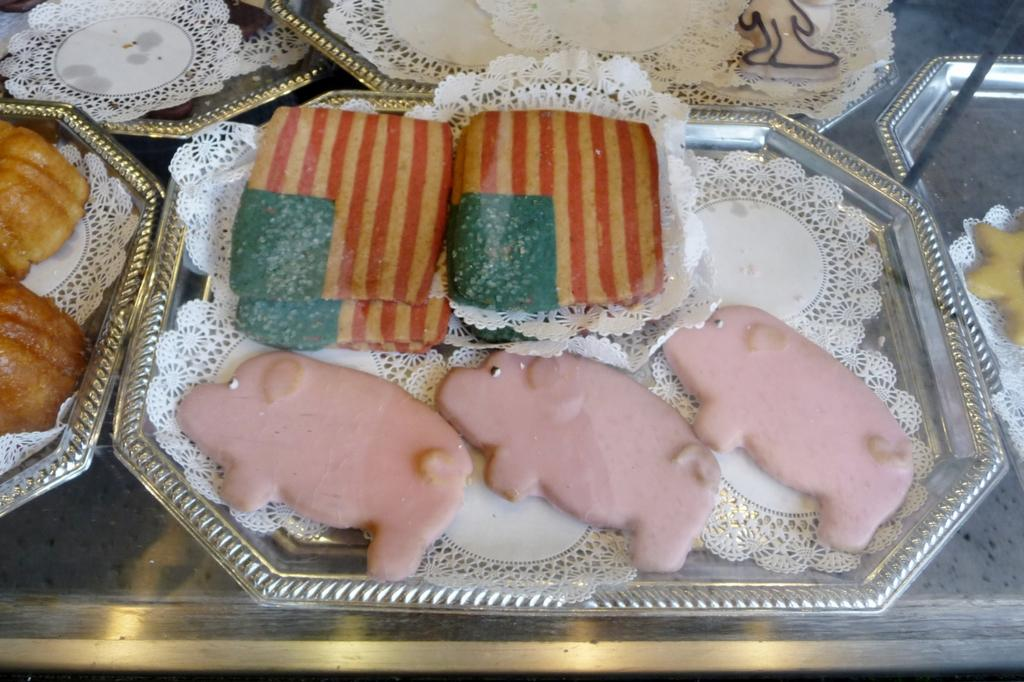How many trays with food items can be seen in the image? There are five trays with food items in the image. What else can be seen in the image besides the trays? There are plates visible in the image. Where might the trays and plates be located in the image? The trays and plates may be on a table in the image. In which type of setting is the image taken? The image is taken in a room. How many trampolines are visible in the image? There are no trampolines visible in the image; it features trays with food items and plates. Can you see any icicles hanging from the ceiling in the image? There are no icicles visible in the image; it is taken in a room, and the presence of icicles would be unlikely in such a setting. 